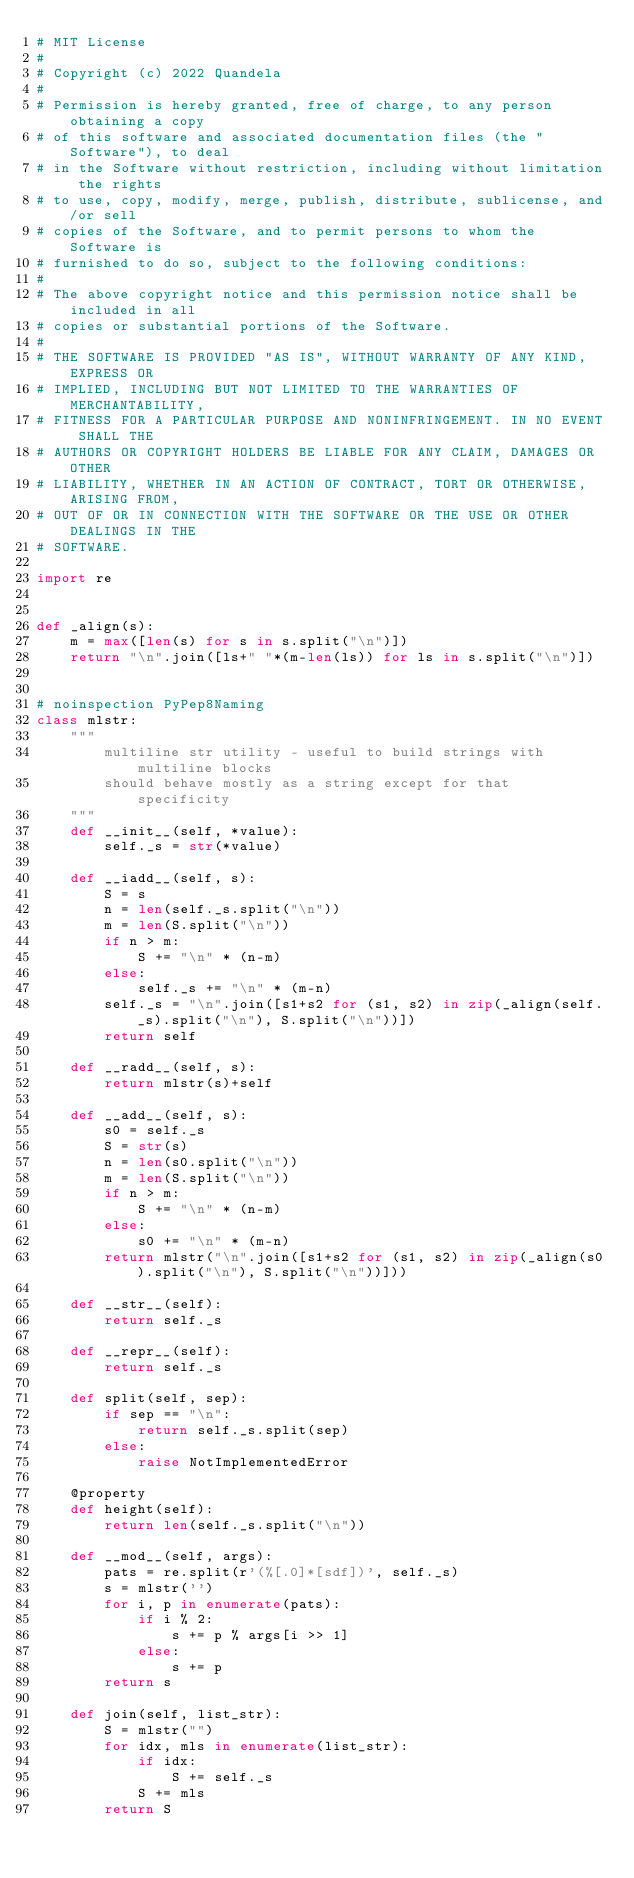<code> <loc_0><loc_0><loc_500><loc_500><_Python_># MIT License
#
# Copyright (c) 2022 Quandela
#
# Permission is hereby granted, free of charge, to any person obtaining a copy
# of this software and associated documentation files (the "Software"), to deal
# in the Software without restriction, including without limitation the rights
# to use, copy, modify, merge, publish, distribute, sublicense, and/or sell
# copies of the Software, and to permit persons to whom the Software is
# furnished to do so, subject to the following conditions:
#
# The above copyright notice and this permission notice shall be included in all
# copies or substantial portions of the Software.
#
# THE SOFTWARE IS PROVIDED "AS IS", WITHOUT WARRANTY OF ANY KIND, EXPRESS OR
# IMPLIED, INCLUDING BUT NOT LIMITED TO THE WARRANTIES OF MERCHANTABILITY,
# FITNESS FOR A PARTICULAR PURPOSE AND NONINFRINGEMENT. IN NO EVENT SHALL THE
# AUTHORS OR COPYRIGHT HOLDERS BE LIABLE FOR ANY CLAIM, DAMAGES OR OTHER
# LIABILITY, WHETHER IN AN ACTION OF CONTRACT, TORT OR OTHERWISE, ARISING FROM,
# OUT OF OR IN CONNECTION WITH THE SOFTWARE OR THE USE OR OTHER DEALINGS IN THE
# SOFTWARE.

import re


def _align(s):
    m = max([len(s) for s in s.split("\n")])
    return "\n".join([ls+" "*(m-len(ls)) for ls in s.split("\n")])


# noinspection PyPep8Naming
class mlstr:
    """
        multiline str utility - useful to build strings with multiline blocks
        should behave mostly as a string except for that specificity
    """
    def __init__(self, *value):
        self._s = str(*value)

    def __iadd__(self, s):
        S = s
        n = len(self._s.split("\n"))
        m = len(S.split("\n"))
        if n > m:
            S += "\n" * (n-m)
        else:
            self._s += "\n" * (m-n)
        self._s = "\n".join([s1+s2 for (s1, s2) in zip(_align(self._s).split("\n"), S.split("\n"))])
        return self

    def __radd__(self, s):
        return mlstr(s)+self

    def __add__(self, s):
        s0 = self._s
        S = str(s)
        n = len(s0.split("\n"))
        m = len(S.split("\n"))
        if n > m:
            S += "\n" * (n-m)
        else:
            s0 += "\n" * (m-n)
        return mlstr("\n".join([s1+s2 for (s1, s2) in zip(_align(s0).split("\n"), S.split("\n"))]))

    def __str__(self):
        return self._s

    def __repr__(self):
        return self._s

    def split(self, sep):
        if sep == "\n":
            return self._s.split(sep)
        else:
            raise NotImplementedError

    @property
    def height(self):
        return len(self._s.split("\n"))

    def __mod__(self, args):
        pats = re.split(r'(%[.0]*[sdf])', self._s)
        s = mlstr('')
        for i, p in enumerate(pats):
            if i % 2:
                s += p % args[i >> 1]
            else:
                s += p
        return s

    def join(self, list_str):
        S = mlstr("")
        for idx, mls in enumerate(list_str):
            if idx:
                S += self._s
            S += mls
        return S
</code> 